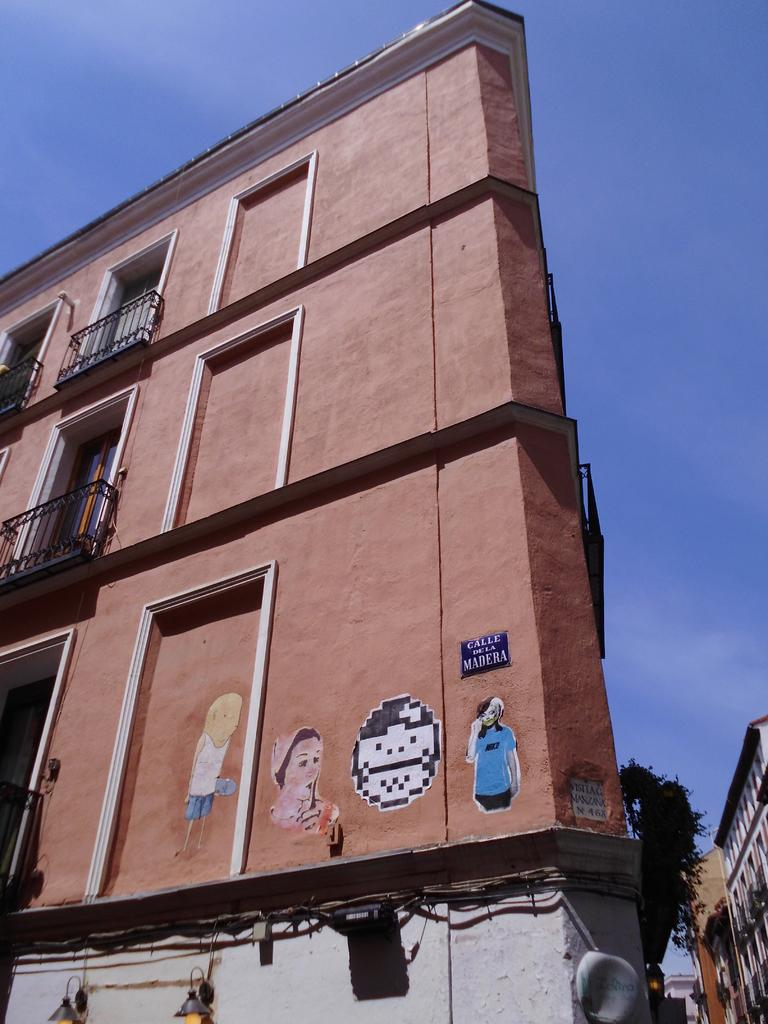What type of structures are located at the bottom of the image? There are buildings with windows at the bottom of the image. What can be seen in the sky at the top of the image? The sky is visible at the top of the image. What type of bread is being used to make the jeans in the image? There is no bread or jeans present in the image. Can you tell me how many elbows are visible in the image? There are no elbows visible in the image. 